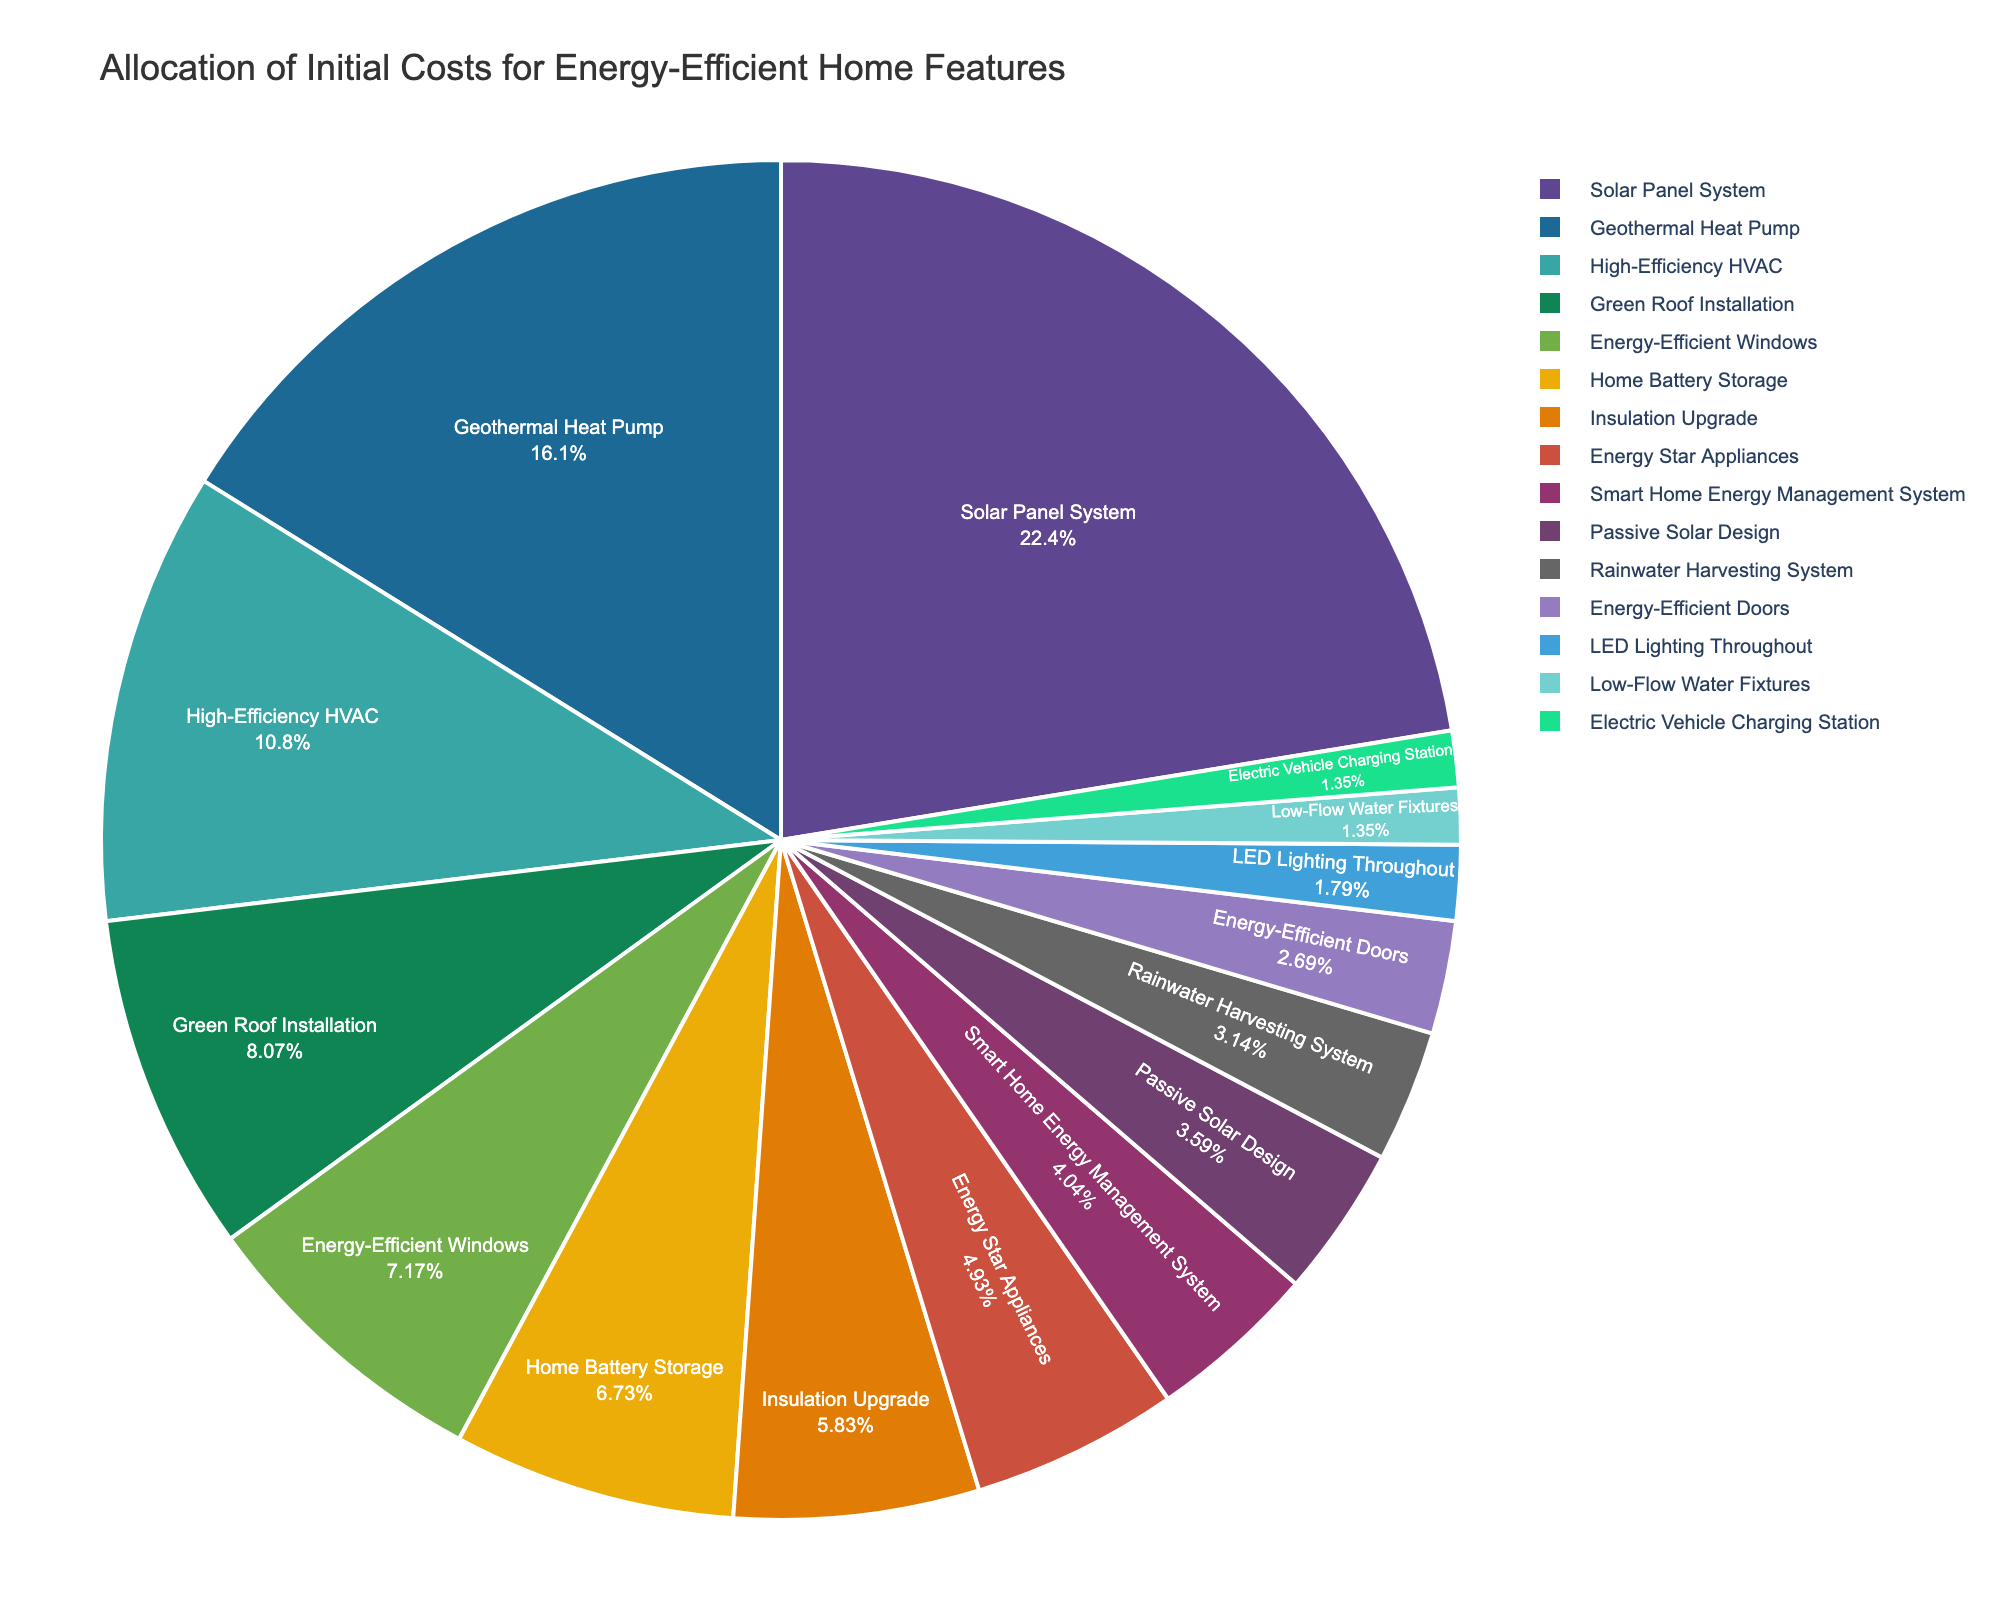Which feature has the largest allocation of initial costs? The pie chart shows the allocation of initial costs for each feature in the figure. The segment with the largest percentage or the largest visual portion represents the feature with the largest allocation.
Answer: Solar Panel System Which feature costs less: High-Efficiency HVAC or Geothermal Heat Pump? By comparing the respective segments of High-Efficiency HVAC and Geothermal Heat Pump, we can see that Geothermal Heat Pump's segment is larger, indicating a higher cost.
Answer: High-Efficiency HVAC What is the combined cost of Energy-Efficient Windows and Insulation Upgrade? The figure shows that Energy-Efficient Windows cost 8,000 and Insulation Upgrade costs 6,500. Adding these amounts together gives 8,000 + 6,500.
Answer: 14,500 How much more does the Solar Panel System cost compared to the Smart Home Energy Management System? The Solar Panel System costs 25,000 while the Smart Home Energy Management System costs 4,500. Subtracting these values, we get 25,000 - 4,500.
Answer: 20,500 Which feature has a cost closest to 5,000? The pie chart shows the costs of each feature. Comparing the values, we see that Energy Star Appliances cost is 5,500, which is the closest to 5,000.
Answer: Energy Star Appliances What is the difference in cost between the most expensive feature and the least expensive feature? The Solar Panel System is the most expensive at 25,000 and Low-Flow Water Fixtures is the least expensive at 1,500. The difference is calculated as 25,000 - 1,500.
Answer: 23,500 Which features have costs less than 3,500? Observing the chart, Low-Flow Water Fixtures (1,500), Electric Vehicle Charging Station (1,500), and Rainwater Harvesting System (3,500) are all under 3,500.
Answer: Low-Flow Water Fixtures, Electric Vehicle Charging Station, Rainwater Harvesting System Which color represents the Energy-Efficient Doors feature in the pie chart? By identifying the segment labeled "Energy-Efficient Doors" in the pie chart, we note the segment's color.
Answer: Dependent on chart's color scheme (needs to be seen visually in the chart) Are the costs of Passive Solar Design and Smart Home Energy Management System similar? By assessing their segments, we see that Passive Solar Design costs 4,000 and Smart Home Energy Management System costs 4,500. They are close in value.
Answer: Yes 